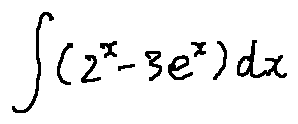Convert formula to latex. <formula><loc_0><loc_0><loc_500><loc_500>\int ( 2 ^ { x } - 3 e ^ { x } ) d x</formula> 